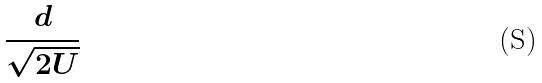<formula> <loc_0><loc_0><loc_500><loc_500>\frac { d } { \sqrt { 2 U } }</formula> 